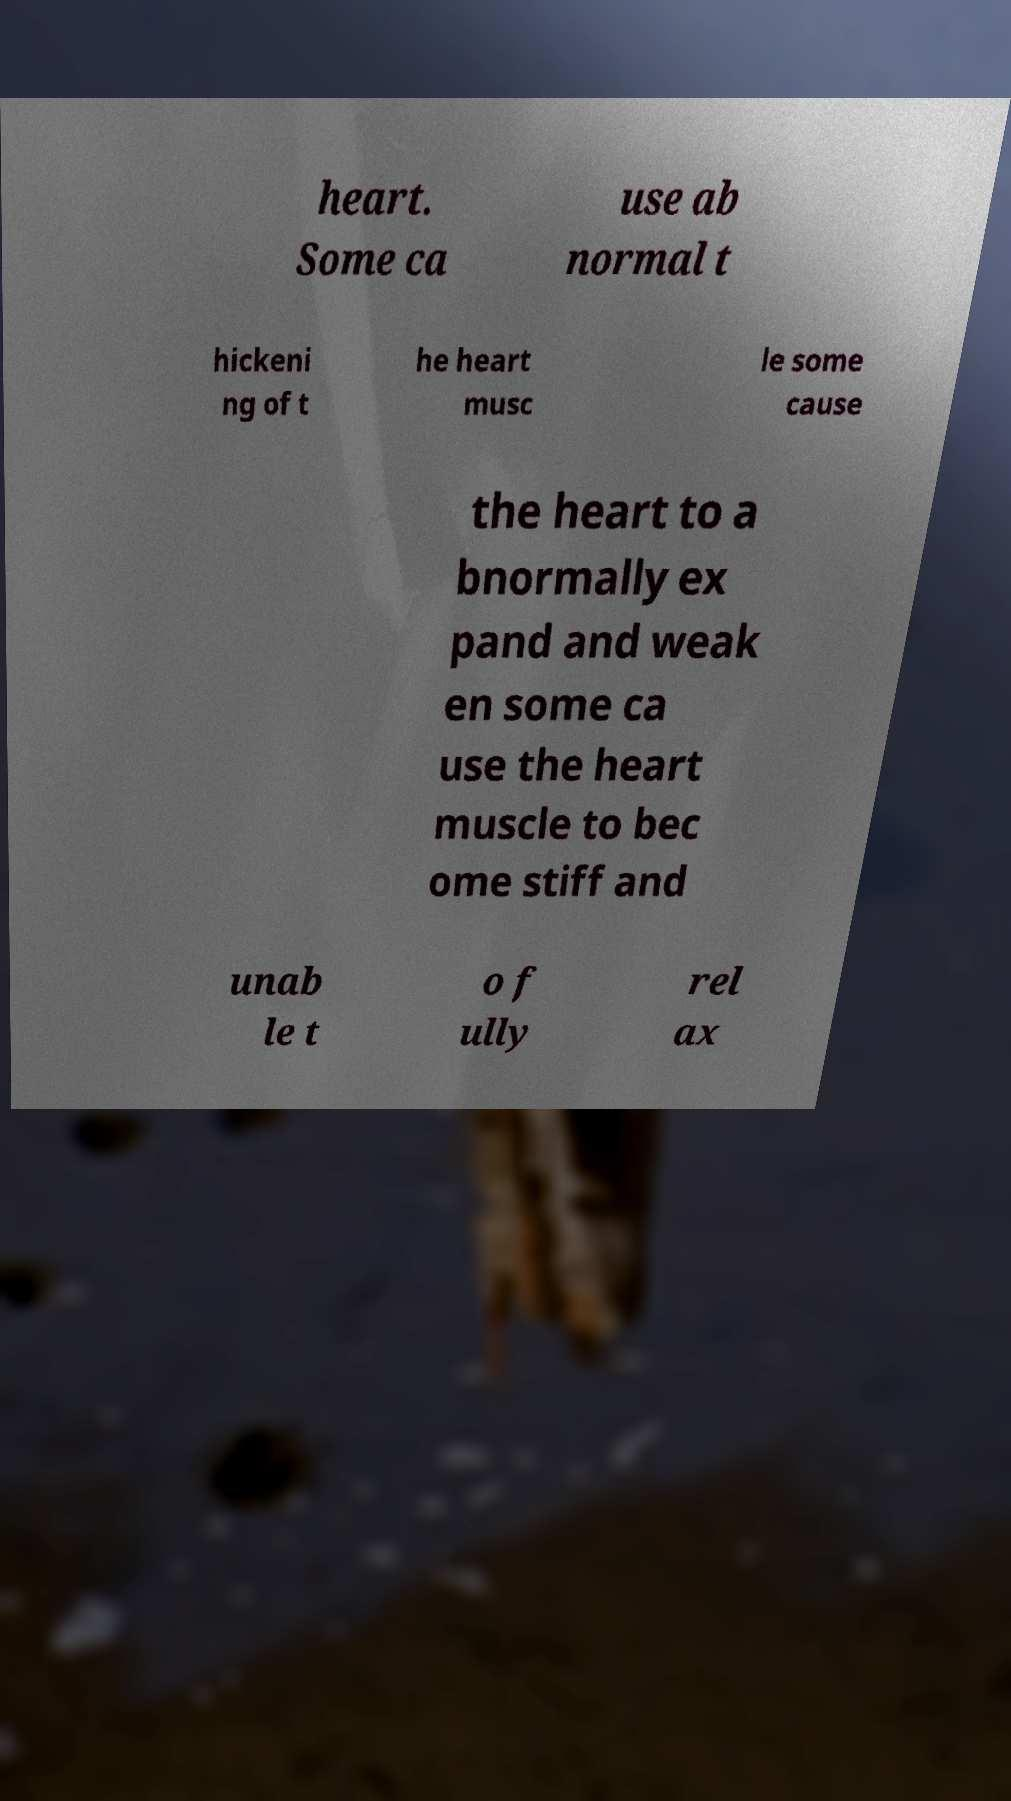Could you extract and type out the text from this image? heart. Some ca use ab normal t hickeni ng of t he heart musc le some cause the heart to a bnormally ex pand and weak en some ca use the heart muscle to bec ome stiff and unab le t o f ully rel ax 